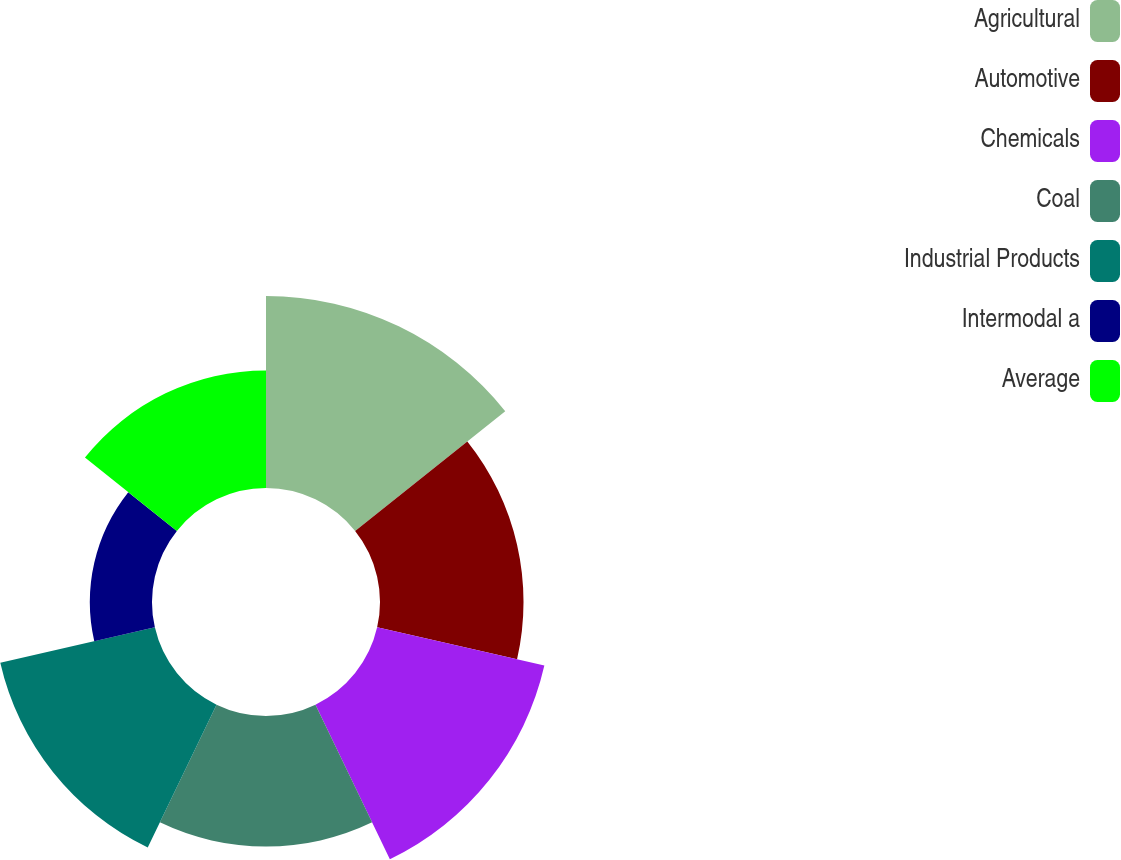Convert chart to OTSL. <chart><loc_0><loc_0><loc_500><loc_500><pie_chart><fcel>Agricultural<fcel>Automotive<fcel>Chemicals<fcel>Coal<fcel>Industrial Products<fcel>Intermodal a<fcel>Average<nl><fcel>19.68%<fcel>14.71%<fcel>17.58%<fcel>13.38%<fcel>16.25%<fcel>6.37%<fcel>12.05%<nl></chart> 